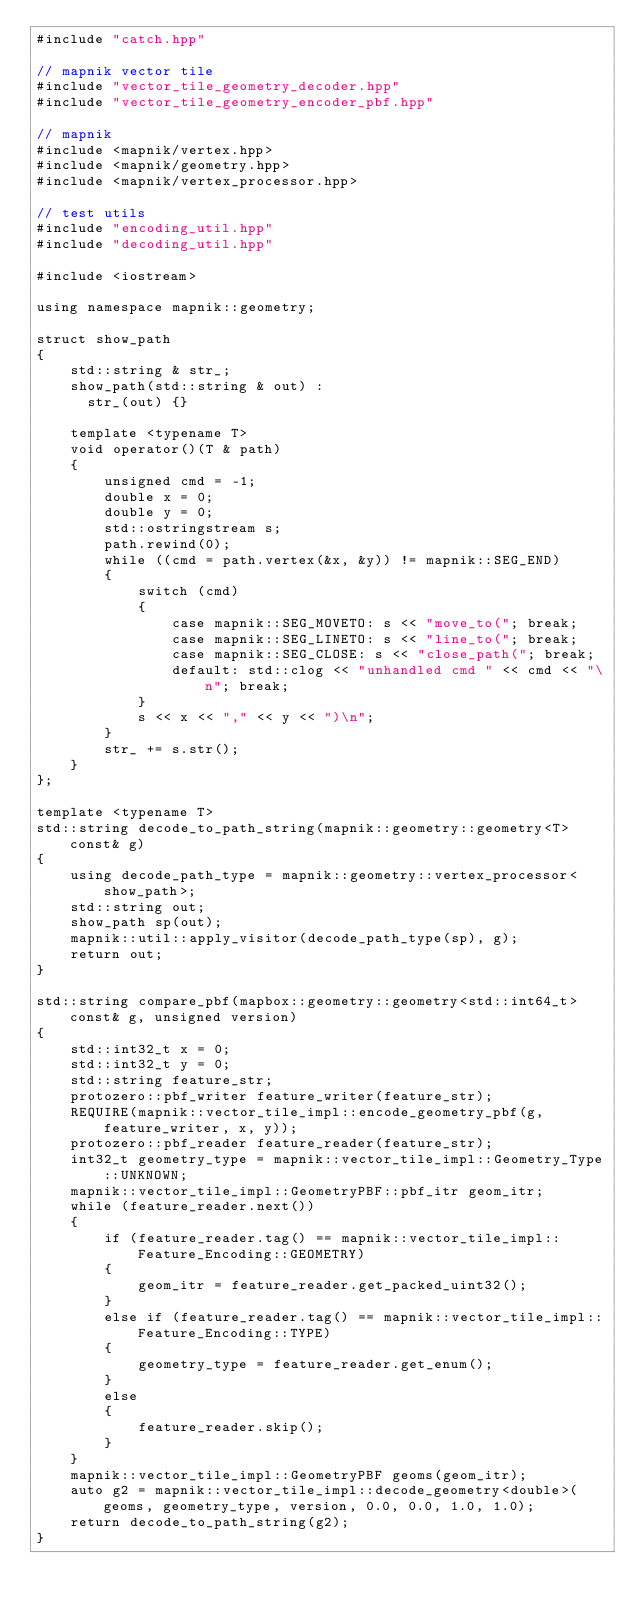Convert code to text. <code><loc_0><loc_0><loc_500><loc_500><_C++_>#include "catch.hpp"

// mapnik vector tile
#include "vector_tile_geometry_decoder.hpp"
#include "vector_tile_geometry_encoder_pbf.hpp"

// mapnik
#include <mapnik/vertex.hpp>
#include <mapnik/geometry.hpp>
#include <mapnik/vertex_processor.hpp>

// test utils
#include "encoding_util.hpp"
#include "decoding_util.hpp"

#include <iostream>

using namespace mapnik::geometry;

struct show_path
{
    std::string & str_;
    show_path(std::string & out) :
      str_(out) {}

    template <typename T>
    void operator()(T & path)
    {
        unsigned cmd = -1;
        double x = 0;
        double y = 0;
        std::ostringstream s;
        path.rewind(0);
        while ((cmd = path.vertex(&x, &y)) != mapnik::SEG_END)
        {
            switch (cmd)
            {
                case mapnik::SEG_MOVETO: s << "move_to("; break;
                case mapnik::SEG_LINETO: s << "line_to("; break;
                case mapnik::SEG_CLOSE: s << "close_path("; break;
                default: std::clog << "unhandled cmd " << cmd << "\n"; break;
            }
            s << x << "," << y << ")\n";
        }
        str_ += s.str();
    }
};

template <typename T>
std::string decode_to_path_string(mapnik::geometry::geometry<T> const& g)
{
    using decode_path_type = mapnik::geometry::vertex_processor<show_path>;
    std::string out;
    show_path sp(out);
    mapnik::util::apply_visitor(decode_path_type(sp), g);
    return out;
}

std::string compare_pbf(mapbox::geometry::geometry<std::int64_t> const& g, unsigned version)
{
    std::int32_t x = 0;
    std::int32_t y = 0;
    std::string feature_str;
    protozero::pbf_writer feature_writer(feature_str);
    REQUIRE(mapnik::vector_tile_impl::encode_geometry_pbf(g, feature_writer, x, y));
    protozero::pbf_reader feature_reader(feature_str);
    int32_t geometry_type = mapnik::vector_tile_impl::Geometry_Type::UNKNOWN; 
    mapnik::vector_tile_impl::GeometryPBF::pbf_itr geom_itr;
    while (feature_reader.next())
    {
        if (feature_reader.tag() == mapnik::vector_tile_impl::Feature_Encoding::GEOMETRY)
        {
            geom_itr = feature_reader.get_packed_uint32();
        }
        else if (feature_reader.tag() == mapnik::vector_tile_impl::Feature_Encoding::TYPE)
        {
            geometry_type = feature_reader.get_enum();
        }
        else
        {
            feature_reader.skip();
        }
    }
    mapnik::vector_tile_impl::GeometryPBF geoms(geom_itr);
    auto g2 = mapnik::vector_tile_impl::decode_geometry<double>(geoms, geometry_type, version, 0.0, 0.0, 1.0, 1.0);
    return decode_to_path_string(g2);
}
</code> 